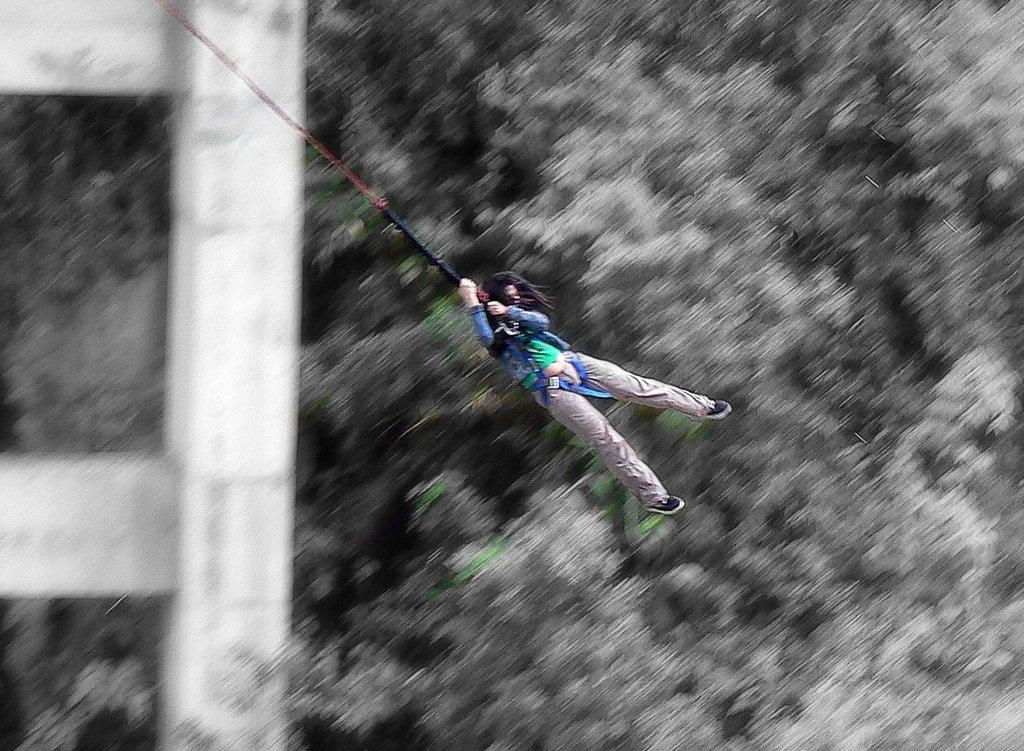What activity is the person in the image engaged in? The person in the image is doing a bungee jump. What can be seen in the background of the image? There are trees and a pillar in the background of the image. How would you describe the appearance of the background? The background appears blurred. What type of power source is visible in the image? There is no power source visible in the image. How can someone join the person doing the bungee jump in the image? The image only shows one person doing a bungee jump, and there is no indication of how someone else could join them. What type of liquid can be seen in the image? There is no liquid visible in the image. 